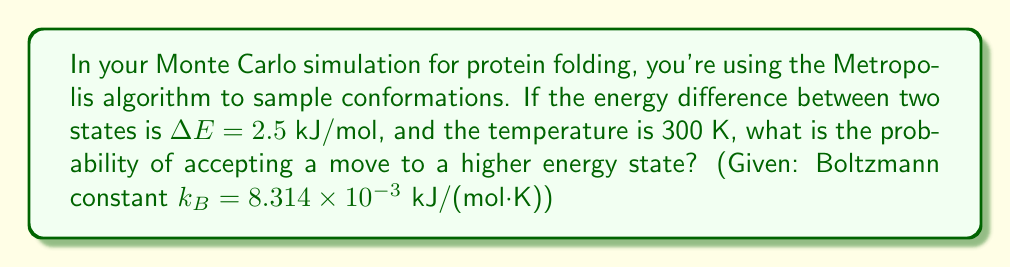Provide a solution to this math problem. 1) The Metropolis algorithm in Monte Carlo simulations for protein folding uses the Boltzmann factor to determine the probability of accepting a move to a higher energy state. This probability is given by:

   $P(\text{accept}) = \exp(-\frac{\Delta E}{k_B T})$

2) We're given:
   $\Delta E = 2.5$ kJ/mol
   $T = 300$ K
   $k_B = 8.314 \times 10^{-3}$ kJ/(mol·K)

3) Substitute these values into the equation:

   $P(\text{accept}) = \exp(-\frac{2.5}{(8.314 \times 10^{-3})(300)})$

4) Simplify the denominator:
   
   $P(\text{accept}) = \exp(-\frac{2.5}{2.4942})$

5) Divide:

   $P(\text{accept}) = \exp(-1.0023)$

6) Calculate the exponential:

   $P(\text{accept}) = 0.3670$

7) Round to three decimal places:

   $P(\text{accept}) \approx 0.367$

This means there's about a 36.7% chance of accepting a move to a higher energy state under these conditions.
Answer: 0.367 